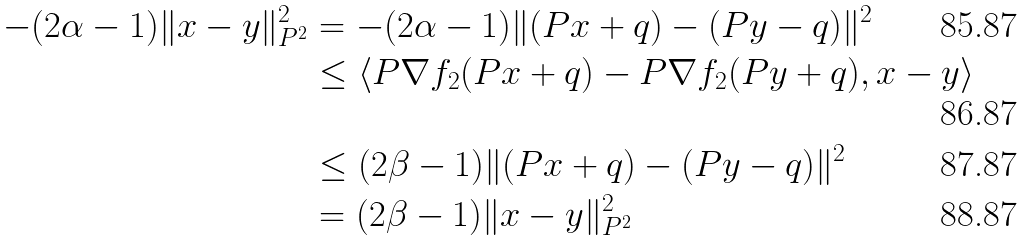<formula> <loc_0><loc_0><loc_500><loc_500>- ( 2 \alpha - 1 ) \| x - y \| _ { P ^ { 2 } } ^ { 2 } & = - ( 2 \alpha - 1 ) \| ( P x + q ) - ( P y - q ) \| ^ { 2 } \\ & \leq \langle P \nabla f _ { 2 } ( P x + q ) - P \nabla f _ { 2 } ( P y + q ) , x - y \rangle \\ & \leq ( 2 \beta - 1 ) \| ( P x + q ) - ( P y - q ) \| ^ { 2 } \\ & = ( 2 \beta - 1 ) \| x - y \| _ { P ^ { 2 } } ^ { 2 }</formula> 